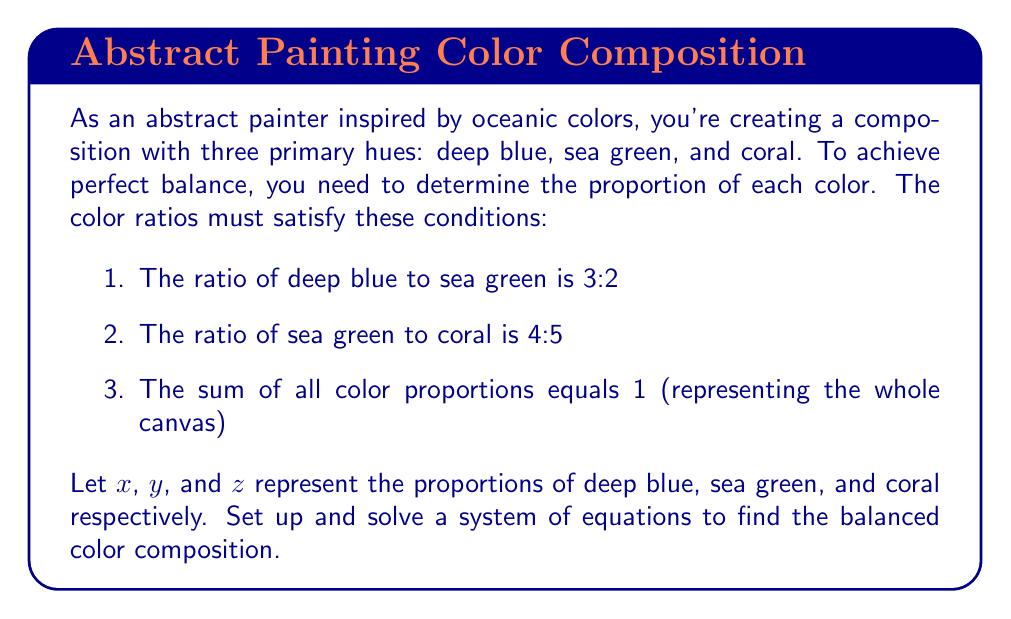Give your solution to this math problem. Let's approach this step-by-step:

1) First, we'll set up the system of equations based on the given conditions:

   From condition 1: $\frac{x}{y} = \frac{3}{2}$
   From condition 2: $\frac{y}{z} = \frac{4}{5}$
   From condition 3: $x + y + z = 1$

2) From the first equation, we can write: $x = \frac{3}{2}y$

3) From the second equation, we can write: $y = \frac{4}{5}z$

4) Substituting these into the third equation:

   $\frac{3}{2}y + y + z = 1$
   $\frac{3}{2}(\frac{4}{5}z) + \frac{4}{5}z + z = 1$

5) Simplify:

   $\frac{6}{5}z + \frac{4}{5}z + z = 1$
   $\frac{6}{5}z + \frac{4}{5}z + \frac{5}{5}z = 1$
   $\frac{15}{5}z = 1$
   $3z = 1$
   $z = \frac{1}{3}$

6) Now we can find y:
   $y = \frac{4}{5}z = \frac{4}{5} \cdot \frac{1}{3} = \frac{4}{15}$

7) And finally, x:
   $x = \frac{3}{2}y = \frac{3}{2} \cdot \frac{4}{15} = \frac{2}{5}$

8) Verify: $\frac{2}{5} + \frac{4}{15} + \frac{1}{3} = \frac{6}{15} + \frac{4}{15} + \frac{5}{15} = 1$

Therefore, the balanced color composition is:
Deep blue (x): $\frac{2}{5}$
Sea green (y): $\frac{4}{15}$
Coral (z): $\frac{1}{3}$
Answer: $$\text{Deep blue} : \text{Sea green} : \text{Coral} = \frac{2}{5} : \frac{4}{15} : \frac{1}{3}$$ 